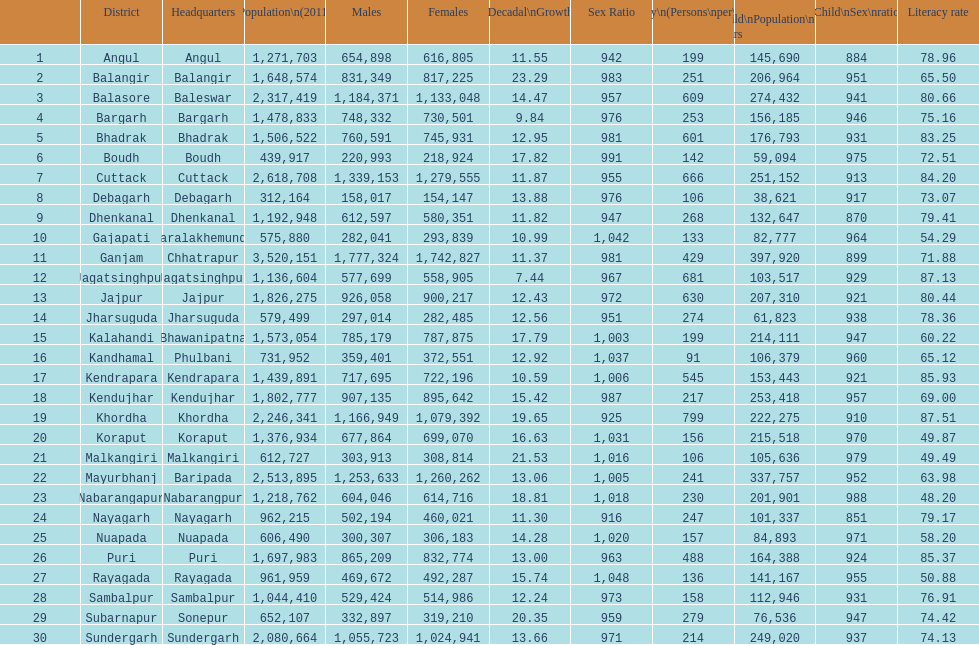How many districts have experienced over 15% decadal growth in percentage? 10. 